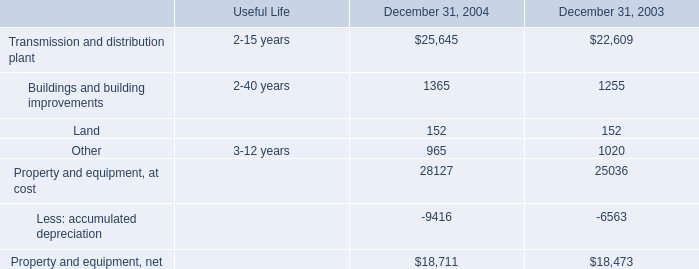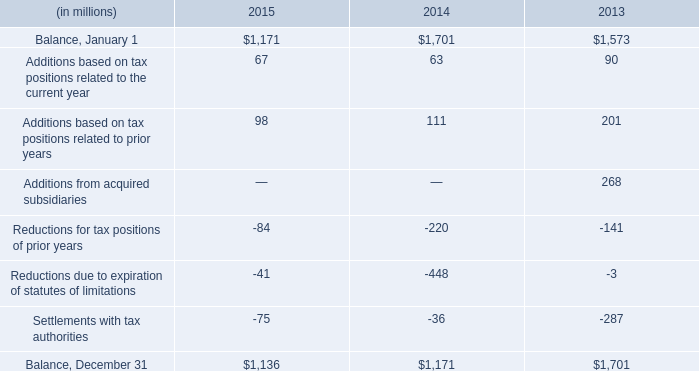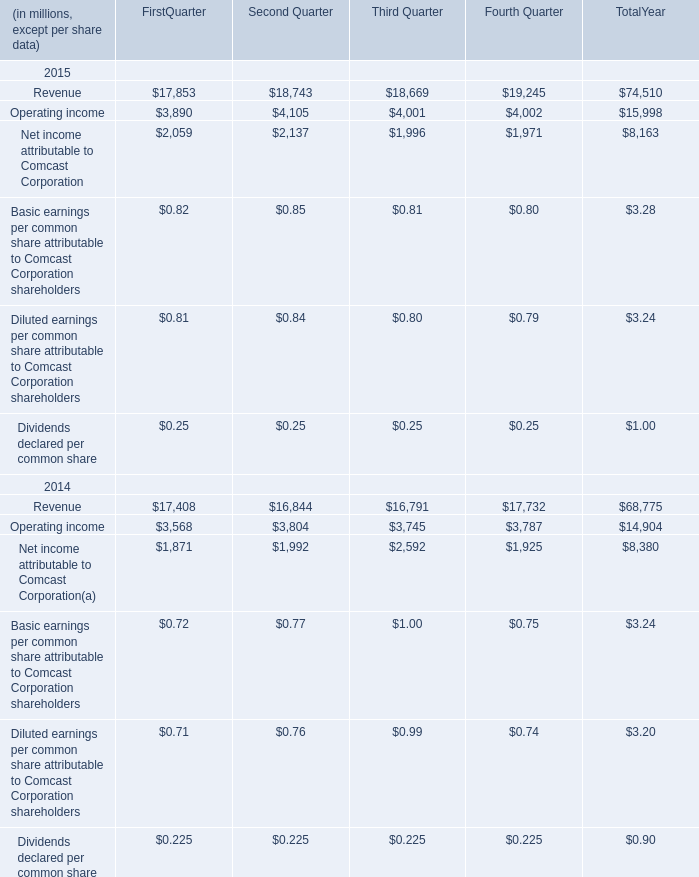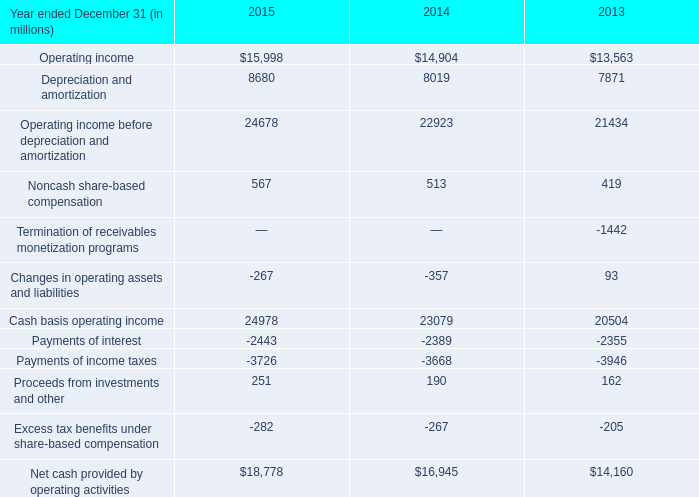What is the average amount of Balance, December 31 of 2015, and Depreciation and amortization of 2013 ? 
Computations: ((1136.0 + 7871.0) / 2)
Answer: 4503.5. 